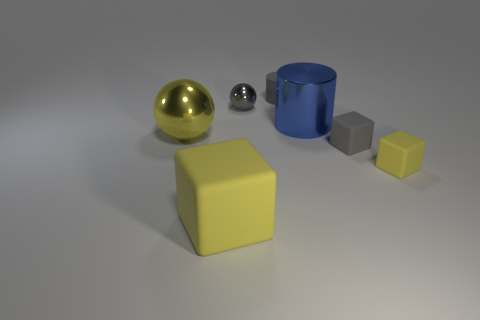Add 1 small gray matte things. How many objects exist? 8 Subtract all blocks. How many objects are left? 4 Add 7 tiny gray cylinders. How many tiny gray cylinders exist? 8 Subtract 0 blue balls. How many objects are left? 7 Subtract all large rubber things. Subtract all large rubber cubes. How many objects are left? 5 Add 3 big things. How many big things are left? 6 